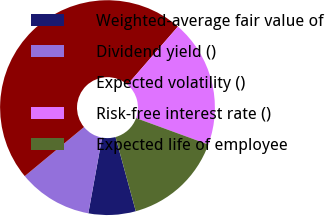Convert chart to OTSL. <chart><loc_0><loc_0><loc_500><loc_500><pie_chart><fcel>Weighted-average fair value of<fcel>Dividend yield ()<fcel>Expected volatility ()<fcel>Risk-free interest rate ()<fcel>Expected life of employee<nl><fcel>7.1%<fcel>11.14%<fcel>47.39%<fcel>19.2%<fcel>15.17%<nl></chart> 